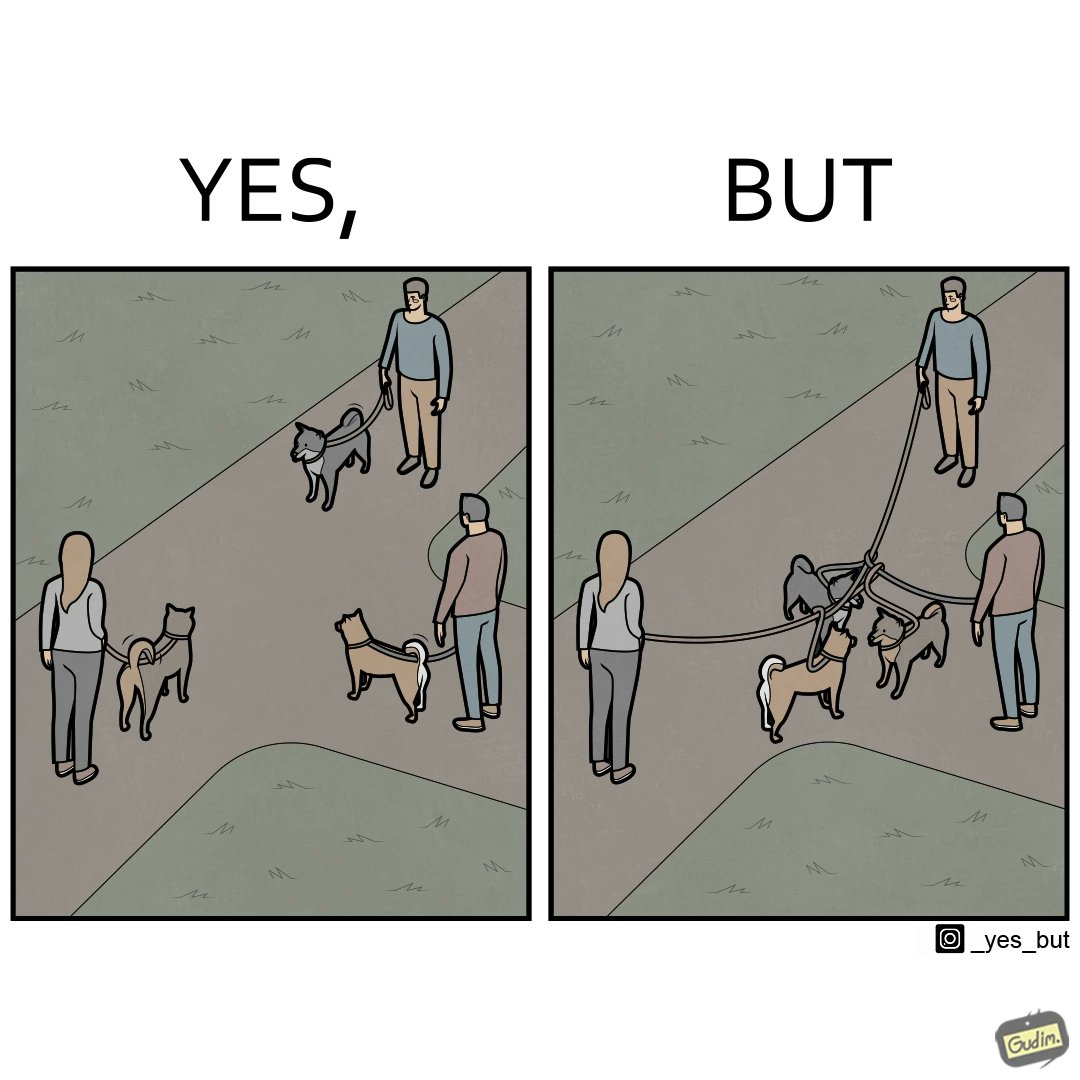Describe the content of this image. The dog owners take their dogs for some walk in parks but their dogs mingle together with other dogs however their leashes get entangled during this which is quite inconvenient for the dog owners 